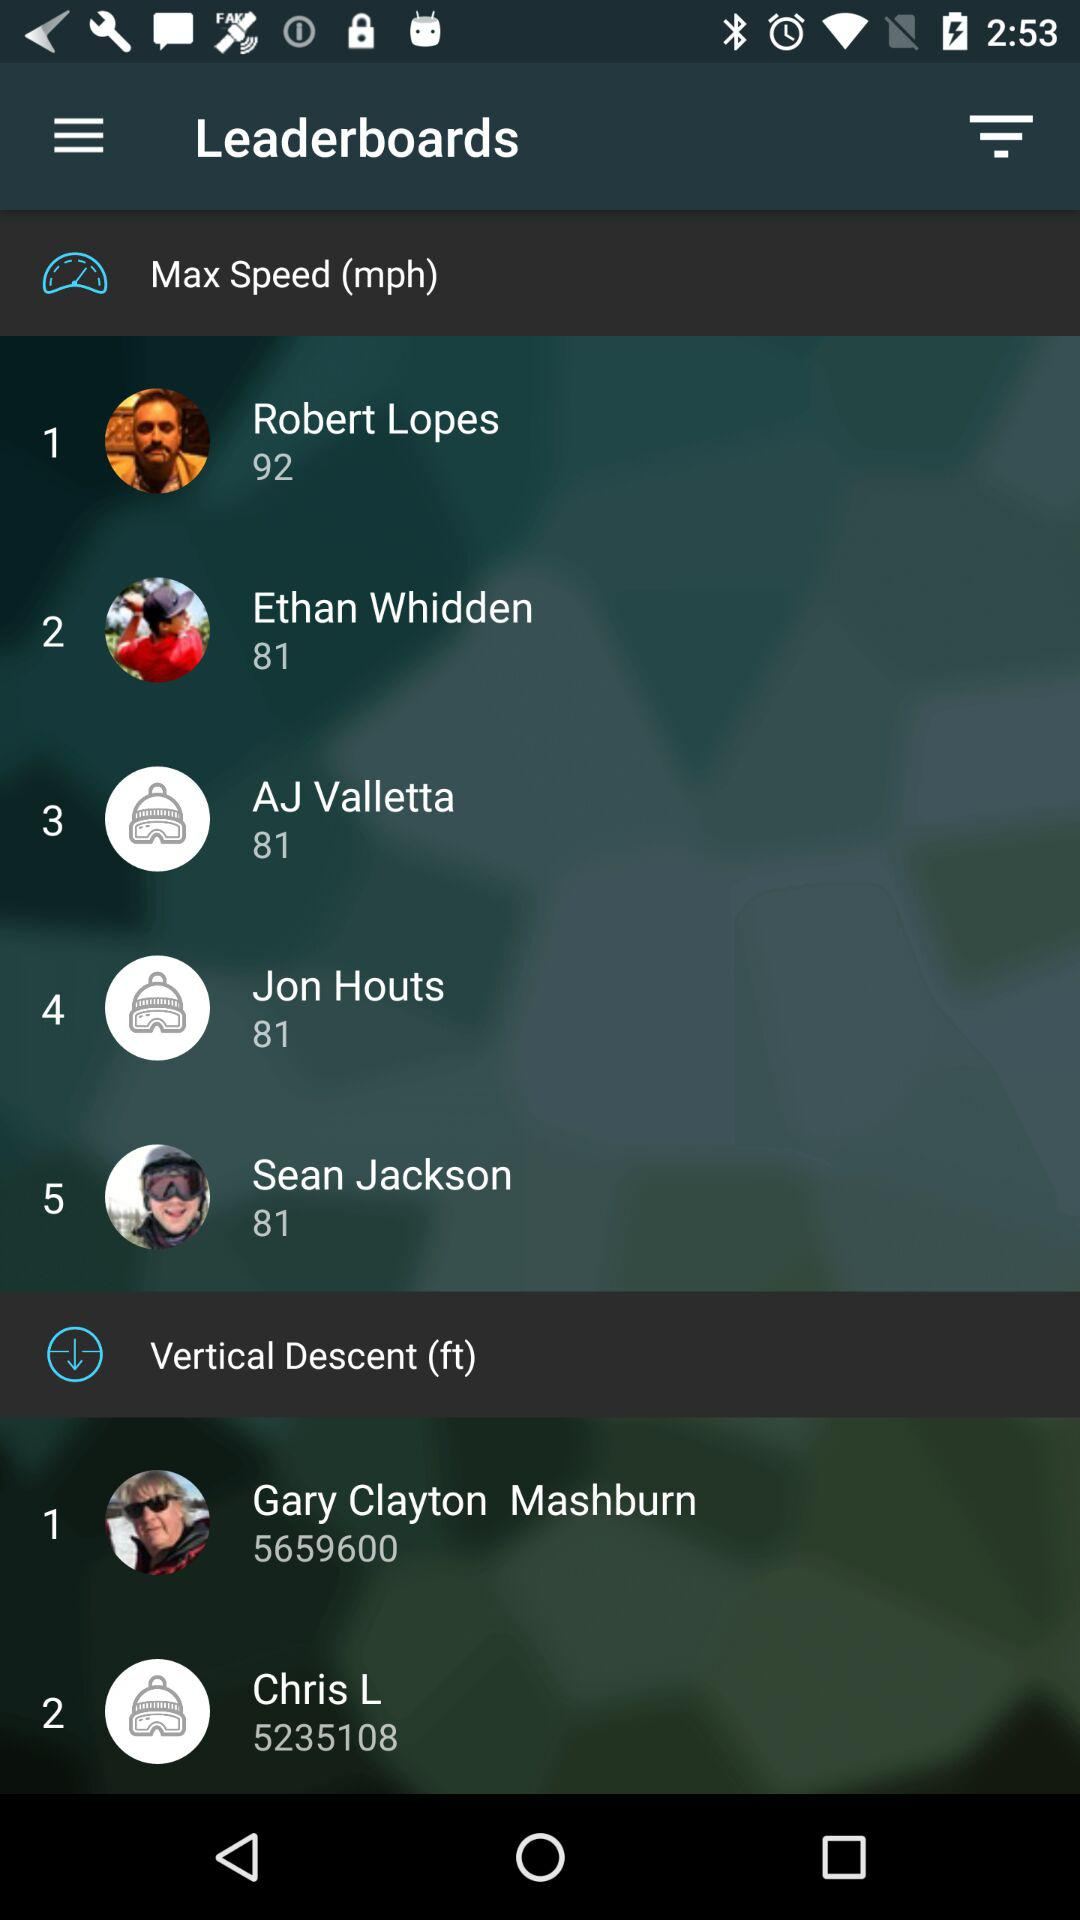What is the name of application?
When the provided information is insufficient, respond with <no answer>. <no answer> 